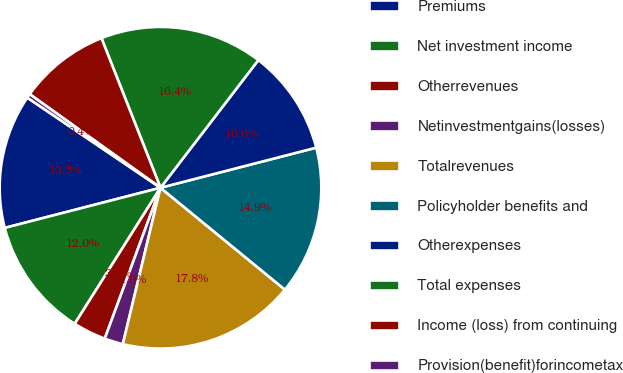Convert chart. <chart><loc_0><loc_0><loc_500><loc_500><pie_chart><fcel>Premiums<fcel>Net investment income<fcel>Otherrevenues<fcel>Netinvestmentgains(losses)<fcel>Totalrevenues<fcel>Policyholder benefits and<fcel>Otherexpenses<fcel>Total expenses<fcel>Income (loss) from continuing<fcel>Provision(benefit)forincometax<nl><fcel>13.48%<fcel>12.03%<fcel>3.32%<fcel>1.87%<fcel>17.84%<fcel>14.93%<fcel>10.58%<fcel>16.39%<fcel>9.13%<fcel>0.42%<nl></chart> 